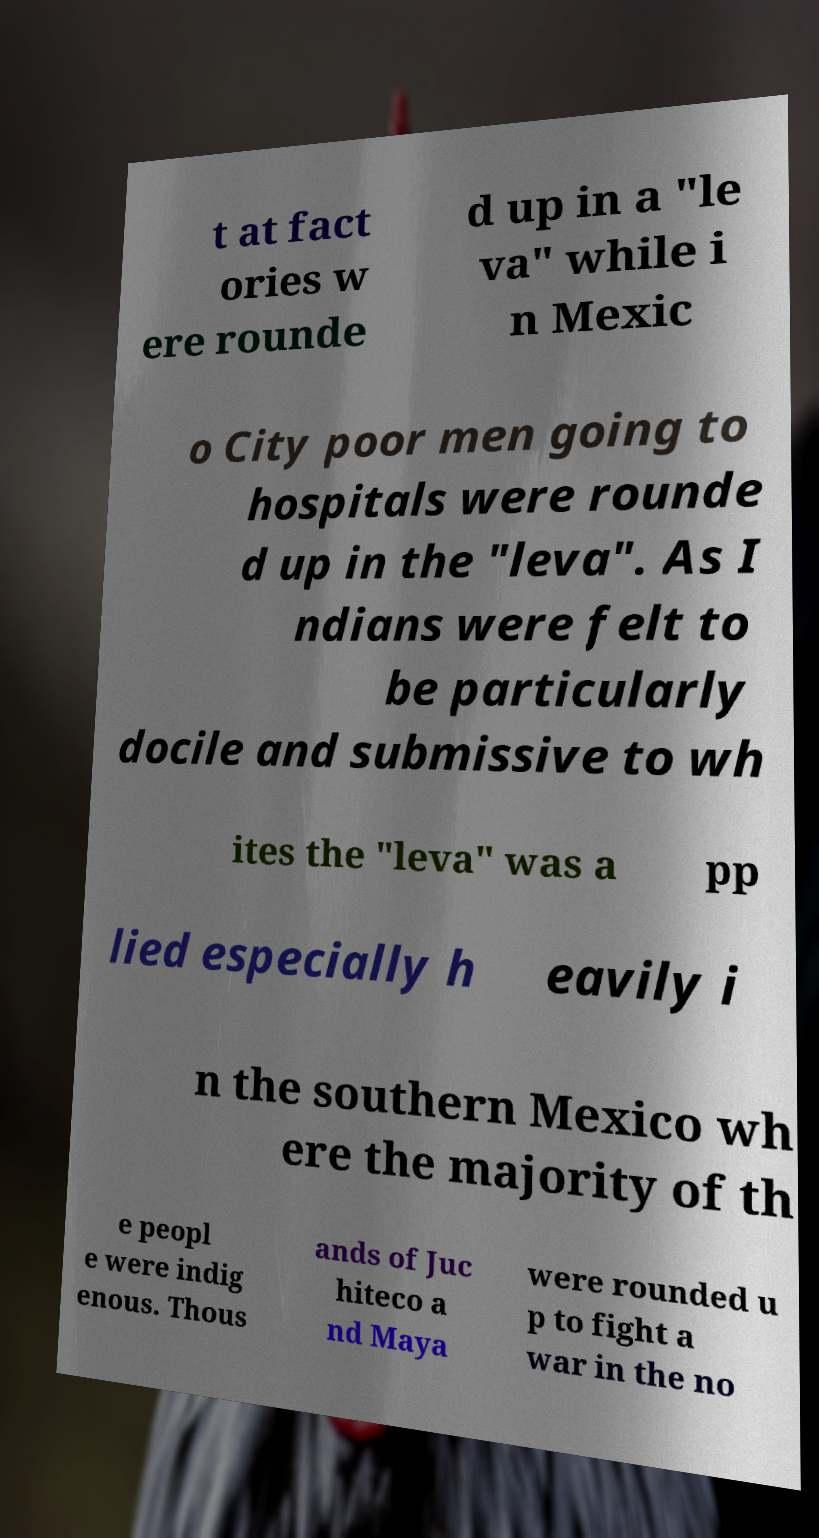Could you assist in decoding the text presented in this image and type it out clearly? t at fact ories w ere rounde d up in a "le va" while i n Mexic o City poor men going to hospitals were rounde d up in the "leva". As I ndians were felt to be particularly docile and submissive to wh ites the "leva" was a pp lied especially h eavily i n the southern Mexico wh ere the majority of th e peopl e were indig enous. Thous ands of Juc hiteco a nd Maya were rounded u p to fight a war in the no 